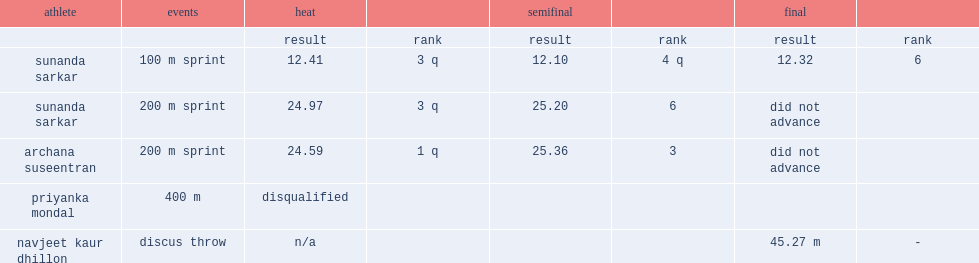Dhillon, at the 2011 commonwealth youth games, how many meters did he have a throw with distance of? 45.27 m. 